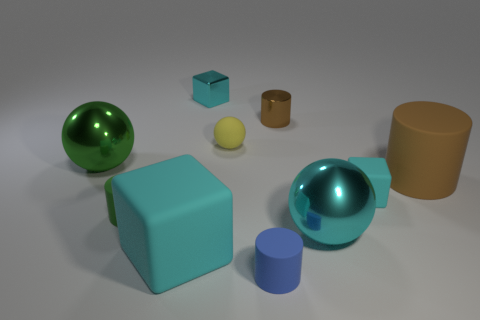What time of day does the lighting in the image suggest, and what mood does it create? The light source in the image appears soft and diffused, suggesting either early morning or late afternoon light. This creates a calm, serene atmosphere, which is complemented by the soft shadows that gently define the shapes of the objects.  Which object appears to have the smoothest surface and what might that imply about its material? The large green glossy sphere appears to have the smoothest surface, reflecting light almost like a mirror. This implies it might be made of a polished, reflective material such as a lacquered wood or a glossy plastic. 